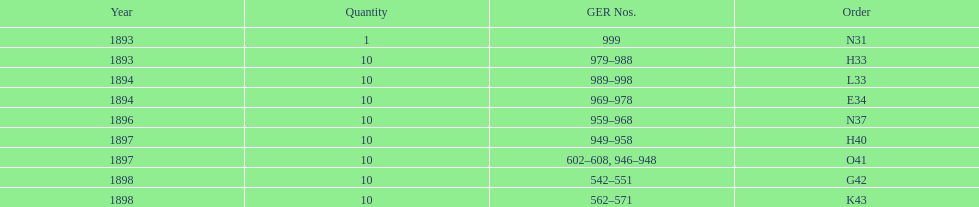Which had more ger numbers, 1898 or 1893? 1898. 